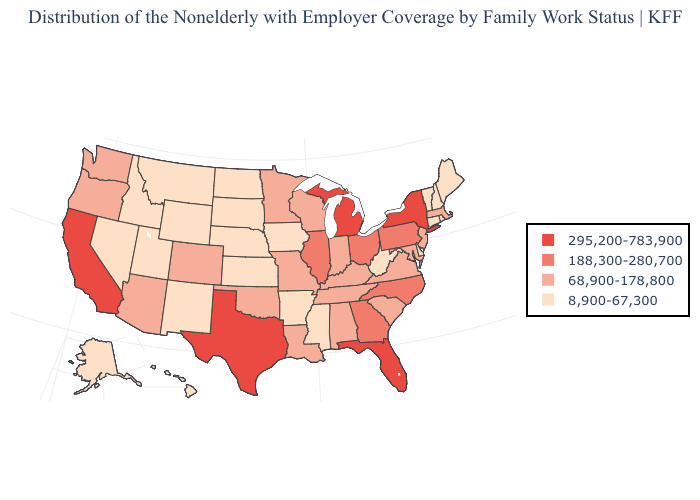Among the states that border Indiana , does Michigan have the highest value?
Concise answer only. Yes. Name the states that have a value in the range 68,900-178,800?
Write a very short answer. Alabama, Arizona, Colorado, Indiana, Kentucky, Louisiana, Maryland, Massachusetts, Minnesota, Missouri, New Jersey, Oklahoma, Oregon, South Carolina, Tennessee, Virginia, Washington, Wisconsin. Name the states that have a value in the range 295,200-783,900?
Short answer required. California, Florida, Michigan, New York, Texas. Among the states that border Minnesota , does Wisconsin have the lowest value?
Keep it brief. No. Does New Mexico have a higher value than North Carolina?
Write a very short answer. No. Name the states that have a value in the range 295,200-783,900?
Quick response, please. California, Florida, Michigan, New York, Texas. What is the value of North Dakota?
Short answer required. 8,900-67,300. Does the map have missing data?
Keep it brief. No. Name the states that have a value in the range 8,900-67,300?
Give a very brief answer. Alaska, Arkansas, Connecticut, Delaware, Hawaii, Idaho, Iowa, Kansas, Maine, Mississippi, Montana, Nebraska, Nevada, New Hampshire, New Mexico, North Dakota, Rhode Island, South Dakota, Utah, Vermont, West Virginia, Wyoming. Does Indiana have the lowest value in the USA?
Quick response, please. No. What is the value of North Dakota?
Be succinct. 8,900-67,300. Which states have the lowest value in the South?
Short answer required. Arkansas, Delaware, Mississippi, West Virginia. Which states hav the highest value in the MidWest?
Short answer required. Michigan. Which states hav the highest value in the South?
Keep it brief. Florida, Texas. What is the highest value in the USA?
Answer briefly. 295,200-783,900. 